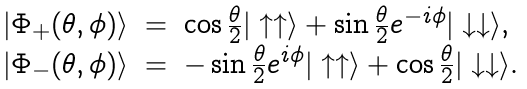<formula> <loc_0><loc_0><loc_500><loc_500>\begin{array} { r c l } | \Phi _ { + } ( \theta , \phi ) \rangle & = & \cos \frac { \theta } { 2 } | \uparrow \uparrow \rangle + \sin \frac { \theta } { 2 } e ^ { - i \phi } | \downarrow \downarrow \rangle , \\ | \Phi _ { - } ( \theta , \phi ) \rangle & = & - \sin \frac { \theta } { 2 } e ^ { i \phi } | \uparrow \uparrow \rangle + \cos \frac { \theta } { 2 } | \downarrow \downarrow \rangle . \end{array}</formula> 